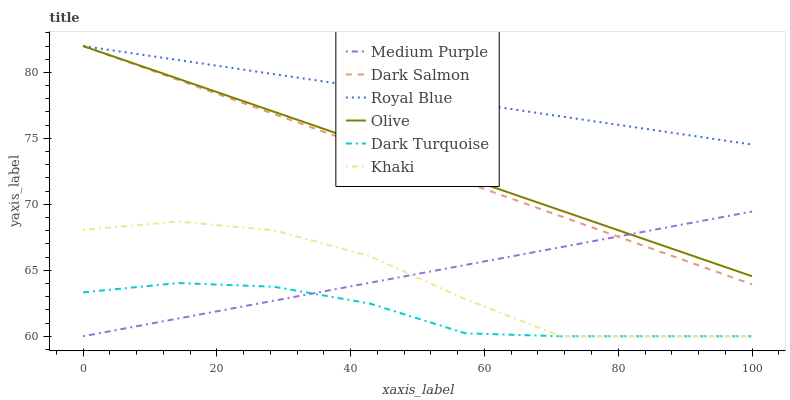Does Dark Turquoise have the minimum area under the curve?
Answer yes or no. Yes. Does Royal Blue have the maximum area under the curve?
Answer yes or no. Yes. Does Dark Salmon have the minimum area under the curve?
Answer yes or no. No. Does Dark Salmon have the maximum area under the curve?
Answer yes or no. No. Is Medium Purple the smoothest?
Answer yes or no. Yes. Is Khaki the roughest?
Answer yes or no. Yes. Is Dark Turquoise the smoothest?
Answer yes or no. No. Is Dark Turquoise the roughest?
Answer yes or no. No. Does Khaki have the lowest value?
Answer yes or no. Yes. Does Dark Salmon have the lowest value?
Answer yes or no. No. Does Olive have the highest value?
Answer yes or no. Yes. Does Dark Turquoise have the highest value?
Answer yes or no. No. Is Medium Purple less than Royal Blue?
Answer yes or no. Yes. Is Dark Salmon greater than Dark Turquoise?
Answer yes or no. Yes. Does Khaki intersect Dark Turquoise?
Answer yes or no. Yes. Is Khaki less than Dark Turquoise?
Answer yes or no. No. Is Khaki greater than Dark Turquoise?
Answer yes or no. No. Does Medium Purple intersect Royal Blue?
Answer yes or no. No. 